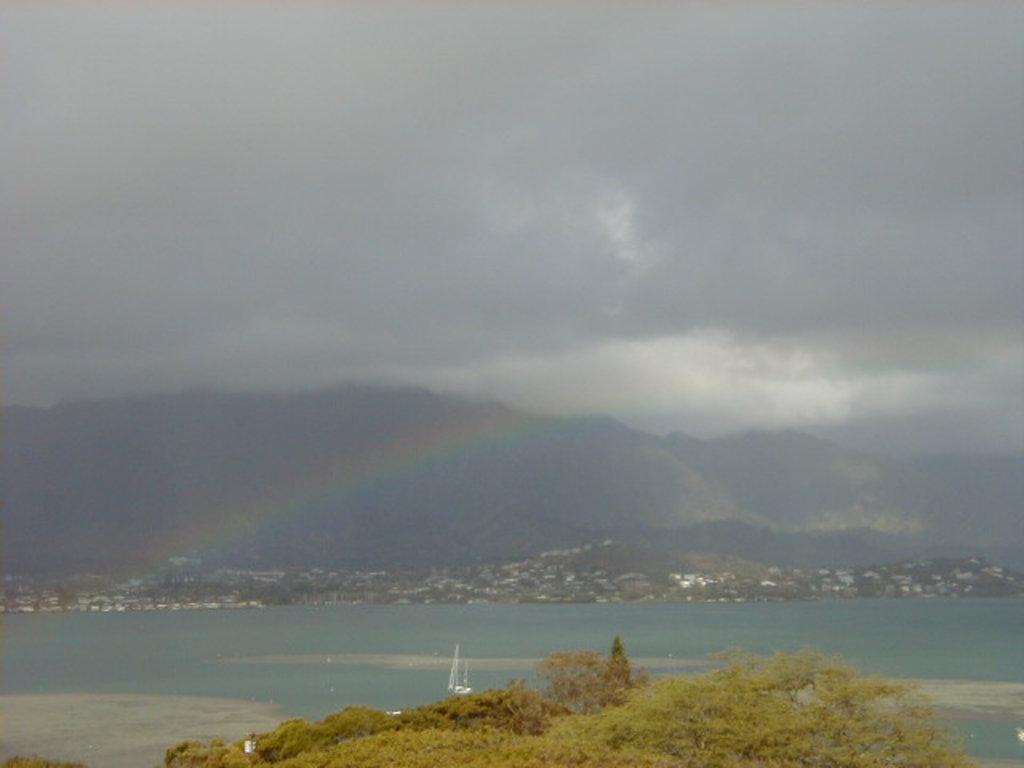How would you summarize this image in a sentence or two? In this picture there is greenery at the bottom side of the image, it seems to be there houses and trees, there is sky at the top side of the image, it seems to be an aerial view. 